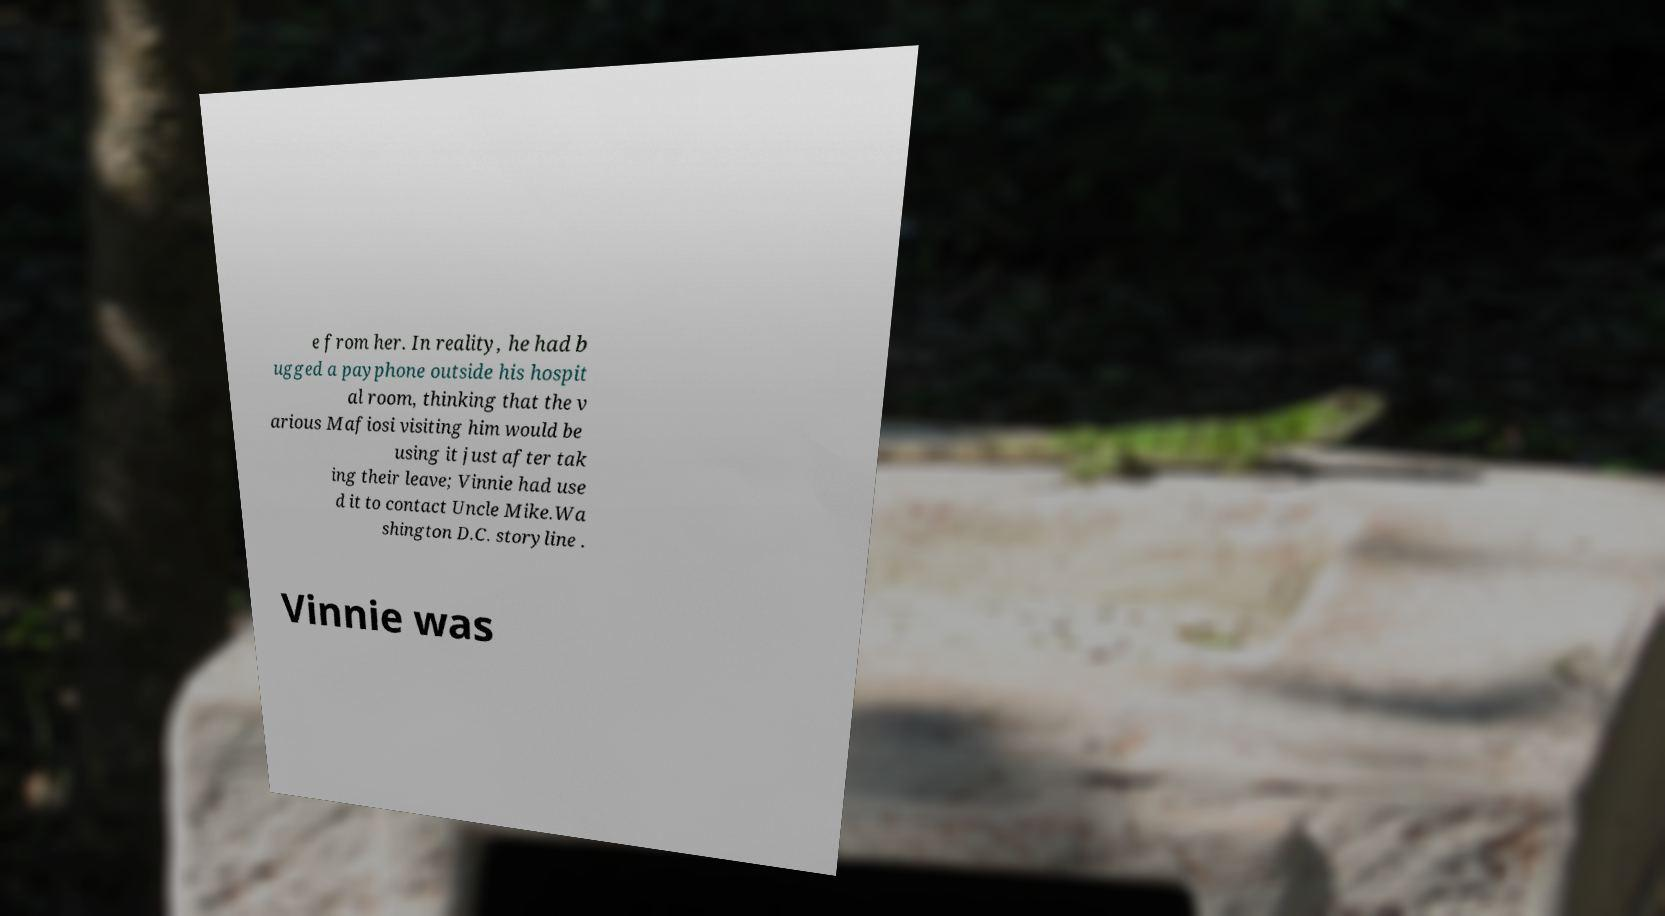Can you read and provide the text displayed in the image?This photo seems to have some interesting text. Can you extract and type it out for me? e from her. In reality, he had b ugged a payphone outside his hospit al room, thinking that the v arious Mafiosi visiting him would be using it just after tak ing their leave; Vinnie had use d it to contact Uncle Mike.Wa shington D.C. storyline . Vinnie was 